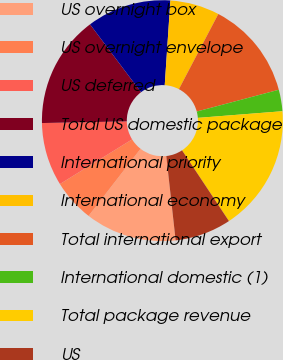<chart> <loc_0><loc_0><loc_500><loc_500><pie_chart><fcel>US overnight box<fcel>US overnight envelope<fcel>US deferred<fcel>Total US domestic package<fcel>International priority<fcel>International economy<fcel>Total international export<fcel>International domestic (1)<fcel>Total package revenue<fcel>US<nl><fcel>12.25%<fcel>5.69%<fcel>8.5%<fcel>15.06%<fcel>11.31%<fcel>6.63%<fcel>13.18%<fcel>2.88%<fcel>16.93%<fcel>7.56%<nl></chart> 